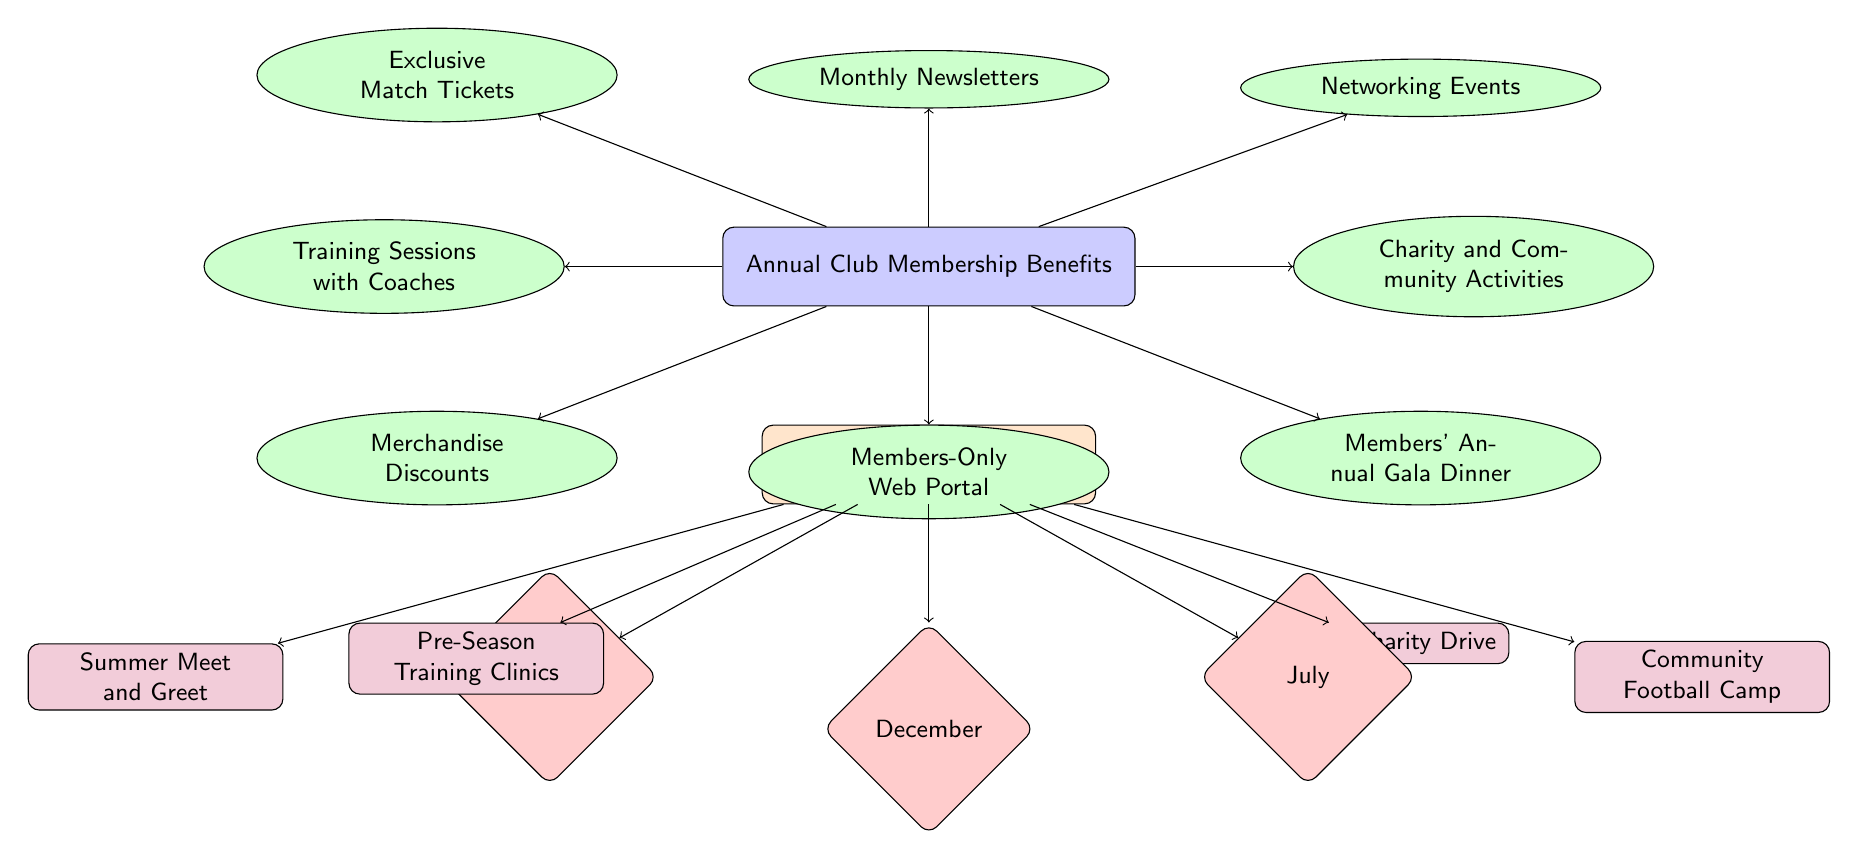What are the benefits of being an annual club member? The diagram lists eight benefits, including Exclusive Match Tickets, Training Sessions with Coaches, Merchandise Discounts, Networking Events, Charity and Community Activities, Members' Annual Gala Dinner, Monthly Newsletters, and Members-Only Web Portal.
Answer: Eight benefits How many activities are scheduled for July? There is one activity scheduled in July, which is the Community Football Camp. The diagram indicates only one event connected to the July month node.
Answer: One activity What is one of the events listed under the activities schedule? The diagram includes multiple events, one of which is the Holiday Charity Drive scheduled for December. This can be identified by locating the December month node and the connected Holiday Charity Drive event node.
Answer: Holiday Charity Drive Which membership benefit involves gathering community support? The corresponding benefit is Charity and Community Activities. This can be seen directly under the Annual Club Membership Benefits section as one of the benefits listed.
Answer: Charity and Community Activities How many months are represented in the activities schedule? The schedule has three distinct months represented: January, December, and July. This can be counted by locating the month nodes in the Activities Schedule section of the diagram.
Answer: Three months What benefit involves direct contact with coaches? The benefit related to direct contact with coaches is Training Sessions with Coaches. This is explicitly noted among the benefits in the diagram.
Answer: Training Sessions with Coaches Which activity is scheduled for January? The Summer Meet and Greet event is scheduled for January. This can be determined by following the connections from the January node to the event node linked to it.
Answer: Summer Meet and Greet What type of shape is used for the benefits in the diagram? The benefits are represented using ellipses. This can be identified by the distinct styling of the nodes labeled as benefits in the diagram.
Answer: Ellipse 